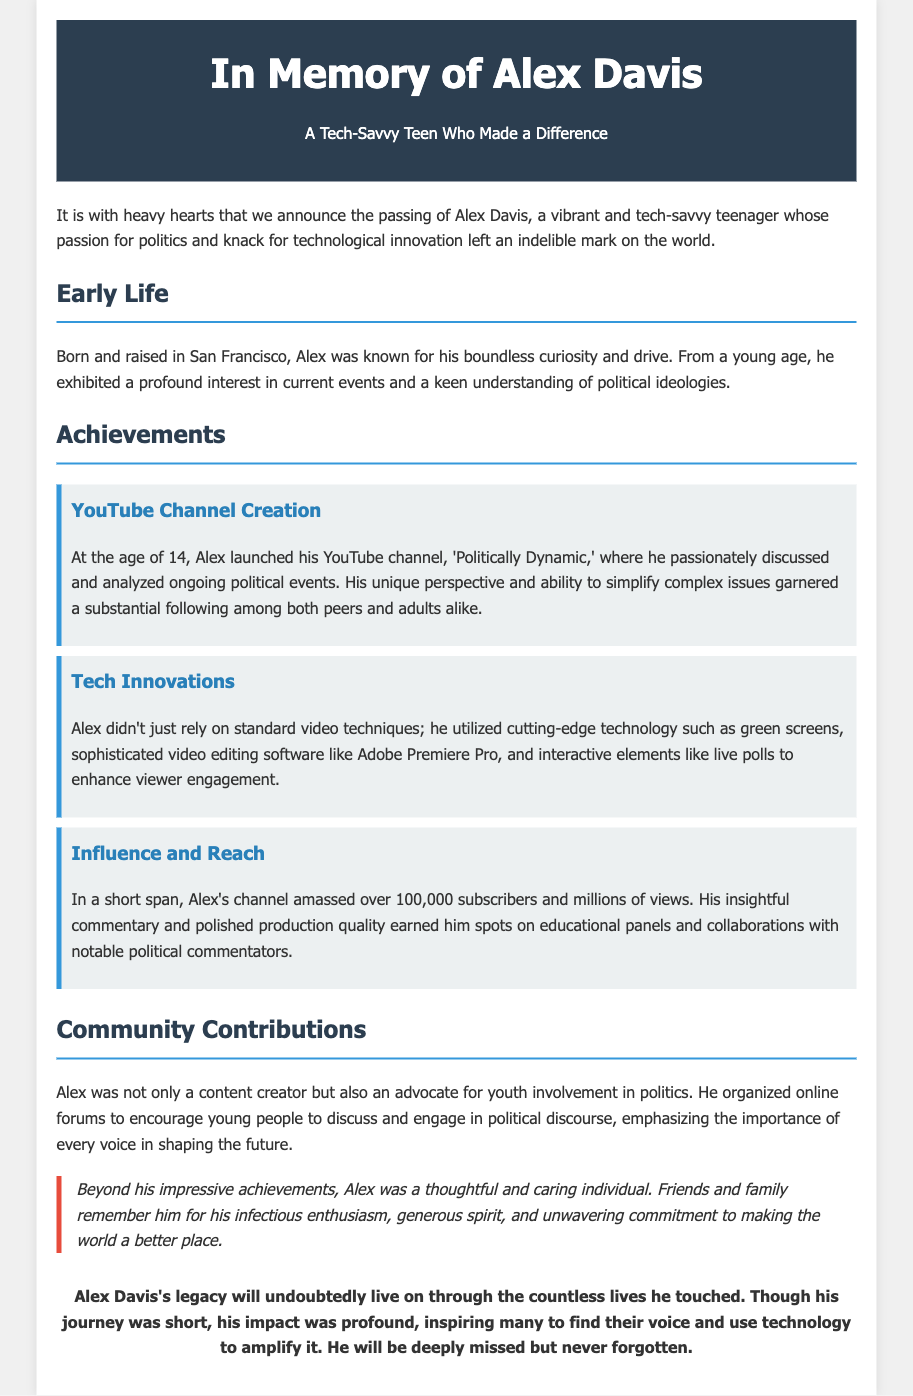what was the name of the teenager? The document states that the teenager's name is Alex Davis.
Answer: Alex Davis where was Alex Davis born? The document mentions that Alex was born and raised in San Francisco.
Answer: San Francisco what age did Alex launch his YouTube channel? The document specifies that Alex launched his YouTube channel at the age of 14.
Answer: 14 how many subscribers did Alex's channel amass? The document states that Alex's channel amassed over 100,000 subscribers.
Answer: 100,000 what kind of technology did Alex use in his productions? The document lists that Alex utilized cutting-edge technology such as green screens and sophisticated video editing software.
Answer: green screens, sophisticated video editing software why did Alex organize online forums? The document explains that Alex wanted to encourage young people to discuss and engage in political discourse.
Answer: encourage youth involvement in politics what kind of individual was Alex described as? The document mentions that Alex was a thoughtful and caring individual.
Answer: thoughtful and caring what was the overall impact of Alex's journey? The document states that Alex's impact was profound, inspiring many to find their voice.
Answer: profound impact 